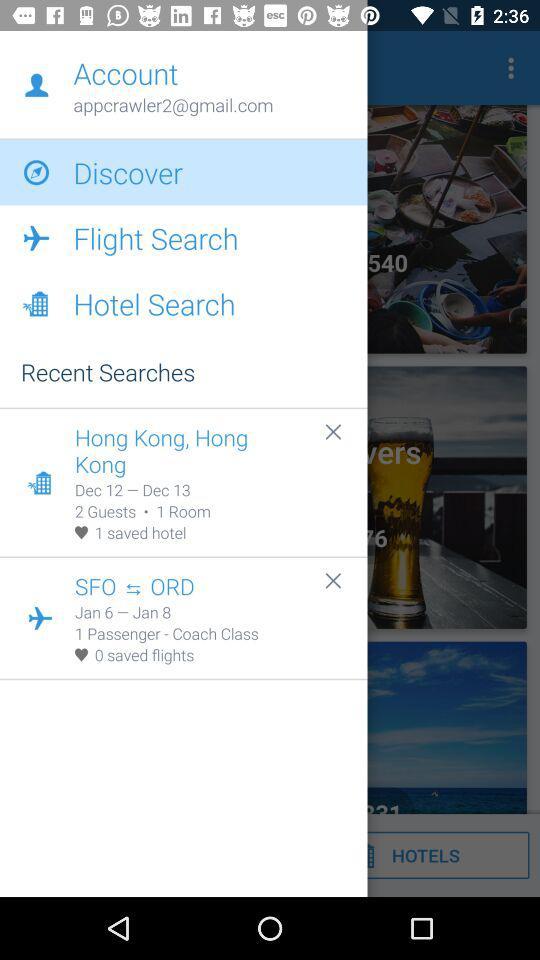What is the number of guests for the hotel in Hong Kong? The number of guests is 2. 